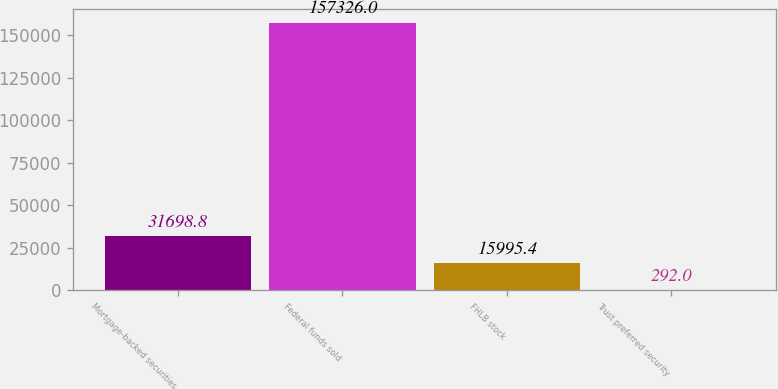Convert chart. <chart><loc_0><loc_0><loc_500><loc_500><bar_chart><fcel>Mortgage-backed securities<fcel>Federal funds sold<fcel>FHLB stock<fcel>Trust preferred security<nl><fcel>31698.8<fcel>157326<fcel>15995.4<fcel>292<nl></chart> 